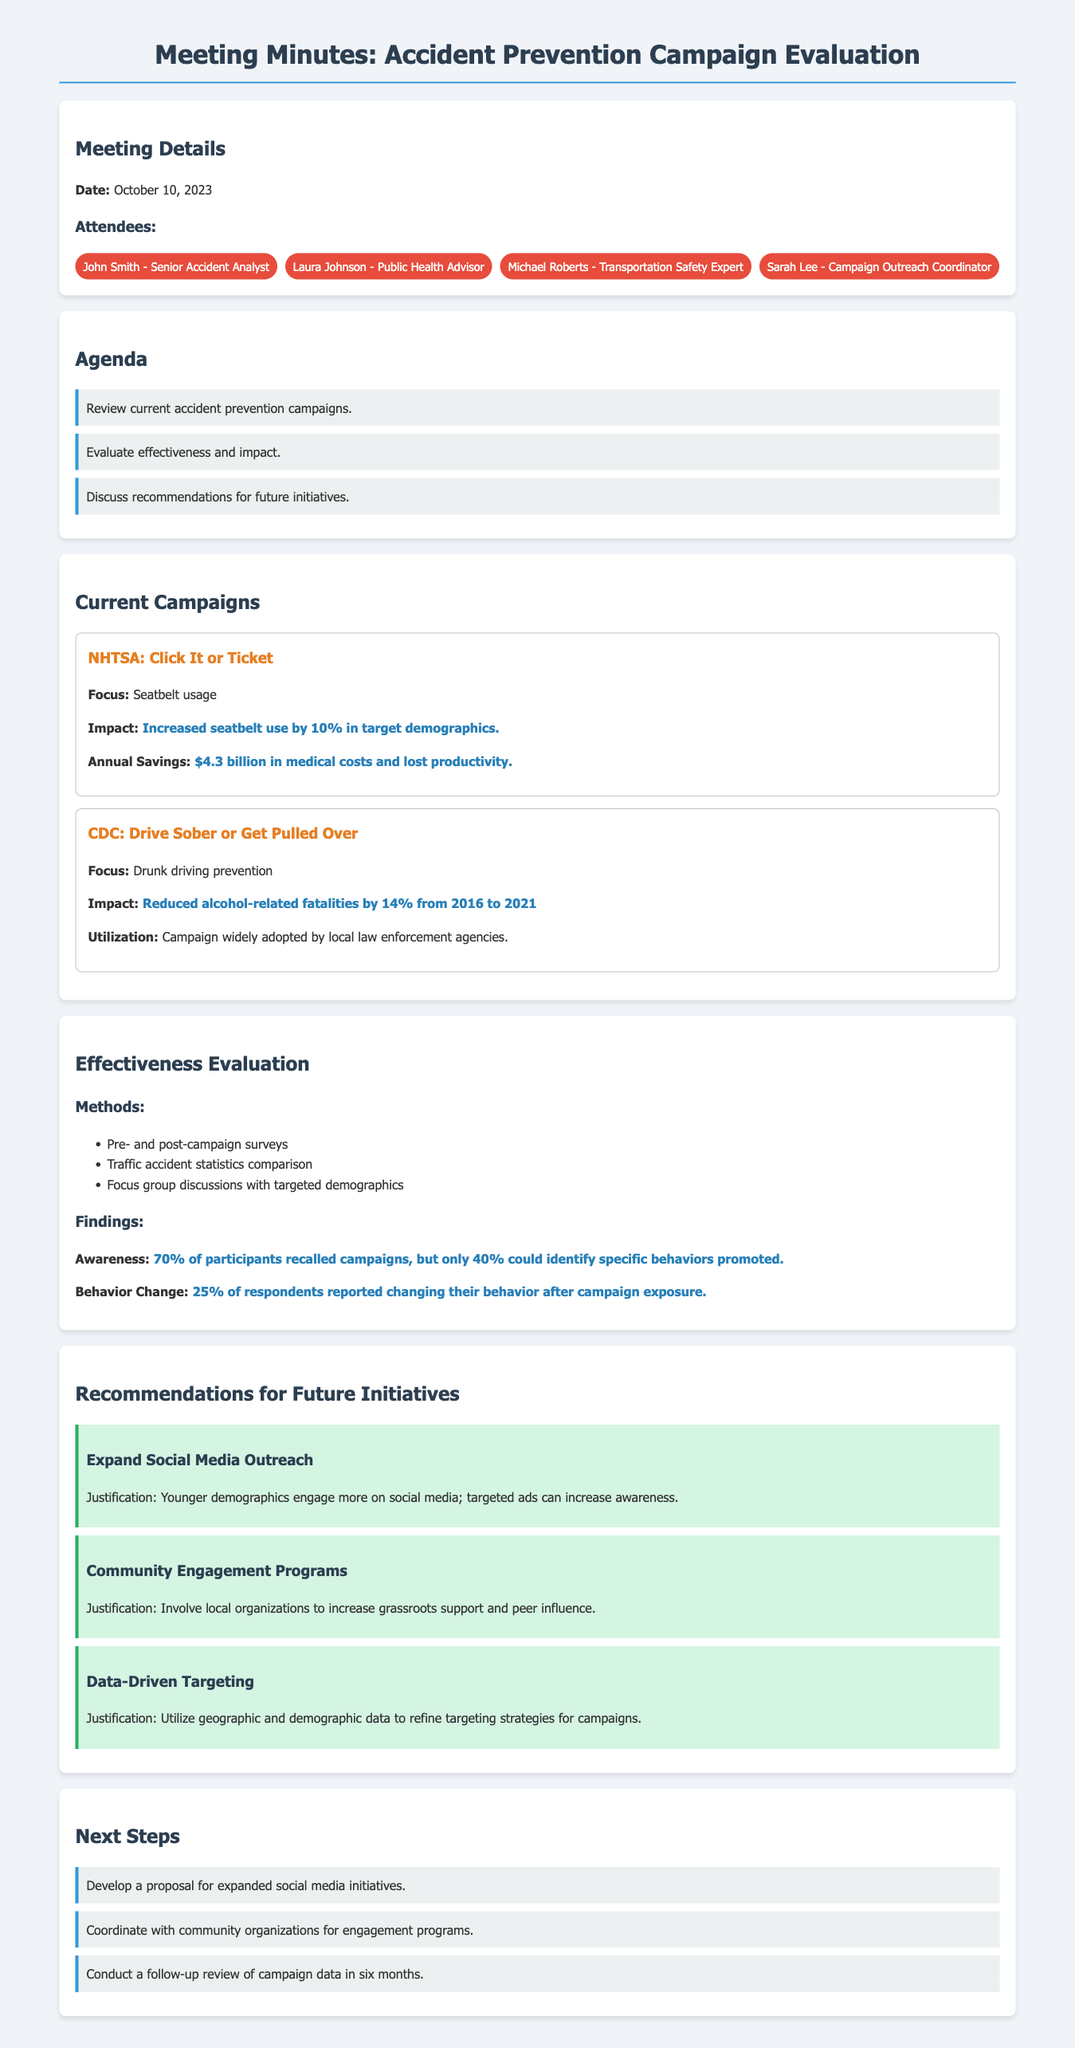What is the date of the meeting? The date of the meeting is stated in the document details section.
Answer: October 10, 2023 Who is the Campaign Outreach Coordinator? The document lists attendees, including the role of Campaign Outreach Coordinator.
Answer: Sarah Lee What percent increase in seatbelt use did the NHTSA campaign achieve? The impact of the NHTSA campaign on seatbelt usage is mentioned in the current campaigns section.
Answer: 10% How much annual savings is attributed to the NHTSA campaign? The document provides financial impact information related to the NHTSA campaign.
Answer: $4.3 billion What was the percentage reduction in alcohol-related fatalities from 2016 to 2021 under the CDC campaign? The effectiveness of the CDC campaign highlights the percentage reduction in fatalities.
Answer: 14% What methods were used to evaluate the effectiveness of campaigns? The evaluation section lists the methods used for assessing campaign effectiveness.
Answer: Pre- and post-campaign surveys, Traffic accident statistics comparison, Focus group discussions What percentage of participants recalled campaigns? The effectiveness evaluation section provides specific data relating to participant recall.
Answer: 70% What is one recommendation for future initiatives? The recommendations section includes suggestions for improving future initiatives.
Answer: Expand Social Media Outreach 